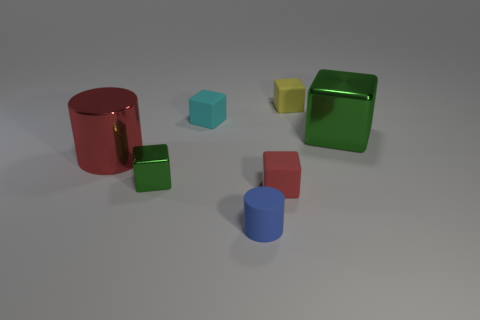Subtract 3 blocks. How many blocks are left? 2 Subtract all cyan cubes. How many cubes are left? 4 Add 1 large red shiny cylinders. How many objects exist? 8 Subtract all cylinders. How many objects are left? 5 Subtract all cyan blocks. Subtract all gray balls. How many blocks are left? 4 Subtract all blue balls. How many cyan cylinders are left? 0 Subtract all large cyan metal cylinders. Subtract all tiny blue matte objects. How many objects are left? 6 Add 7 small cyan blocks. How many small cyan blocks are left? 8 Add 4 cyan blocks. How many cyan blocks exist? 5 Subtract all cyan blocks. How many blocks are left? 4 